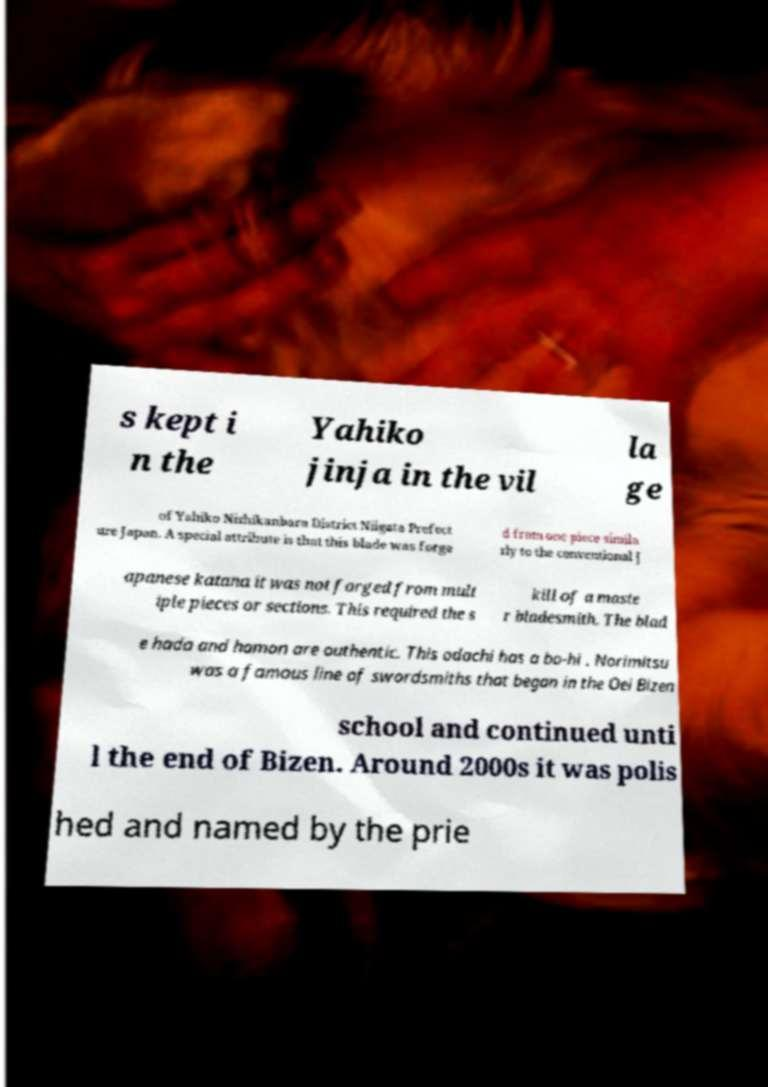There's text embedded in this image that I need extracted. Can you transcribe it verbatim? s kept i n the Yahiko jinja in the vil la ge of Yahiko Nishikanbara District Niigata Prefect ure Japan. A special attribute is that this blade was forge d from one piece simila rly to the conventional J apanese katana it was not forged from mult iple pieces or sections. This required the s kill of a maste r bladesmith. The blad e hada and hamon are authentic. This odachi has a bo-hi . Norimitsu was a famous line of swordsmiths that began in the Oei Bizen school and continued unti l the end of Bizen. Around 2000s it was polis hed and named by the prie 